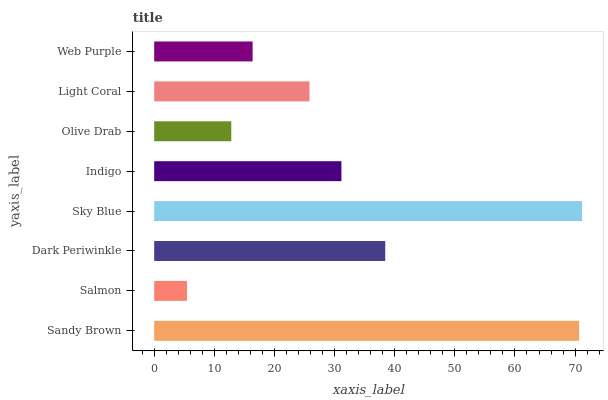Is Salmon the minimum?
Answer yes or no. Yes. Is Sky Blue the maximum?
Answer yes or no. Yes. Is Dark Periwinkle the minimum?
Answer yes or no. No. Is Dark Periwinkle the maximum?
Answer yes or no. No. Is Dark Periwinkle greater than Salmon?
Answer yes or no. Yes. Is Salmon less than Dark Periwinkle?
Answer yes or no. Yes. Is Salmon greater than Dark Periwinkle?
Answer yes or no. No. Is Dark Periwinkle less than Salmon?
Answer yes or no. No. Is Indigo the high median?
Answer yes or no. Yes. Is Light Coral the low median?
Answer yes or no. Yes. Is Dark Periwinkle the high median?
Answer yes or no. No. Is Olive Drab the low median?
Answer yes or no. No. 